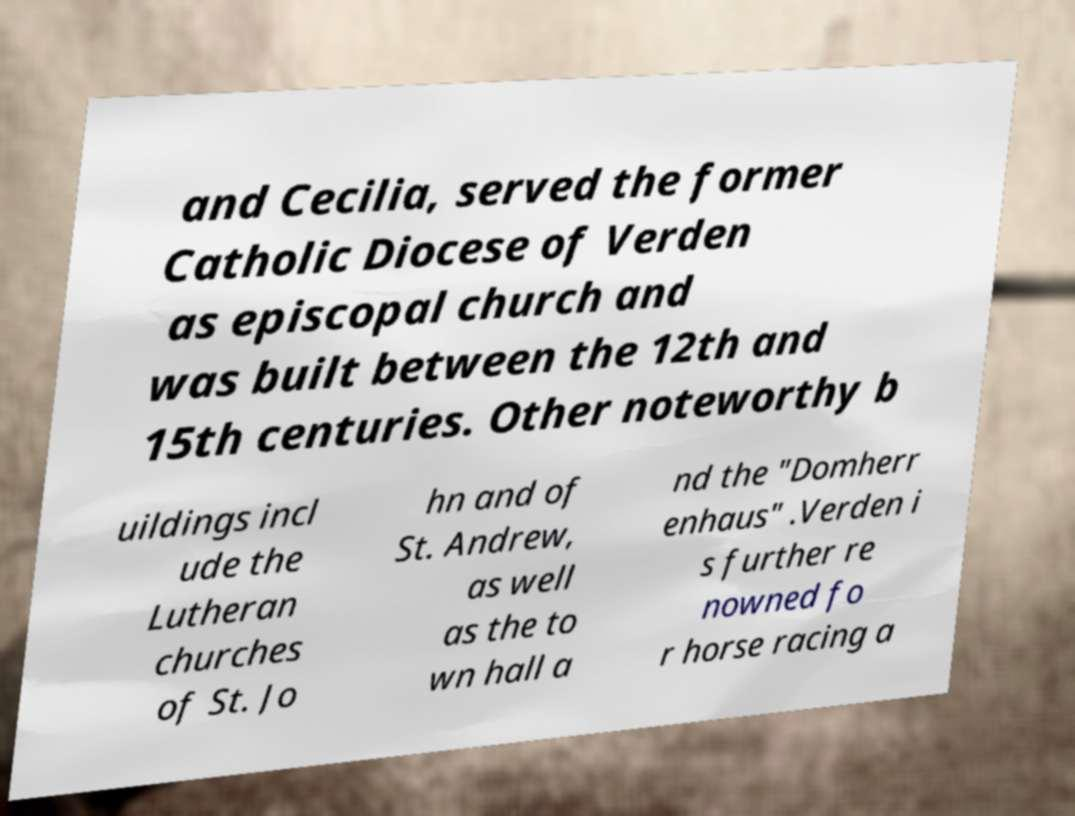Please identify and transcribe the text found in this image. and Cecilia, served the former Catholic Diocese of Verden as episcopal church and was built between the 12th and 15th centuries. Other noteworthy b uildings incl ude the Lutheran churches of St. Jo hn and of St. Andrew, as well as the to wn hall a nd the "Domherr enhaus" .Verden i s further re nowned fo r horse racing a 